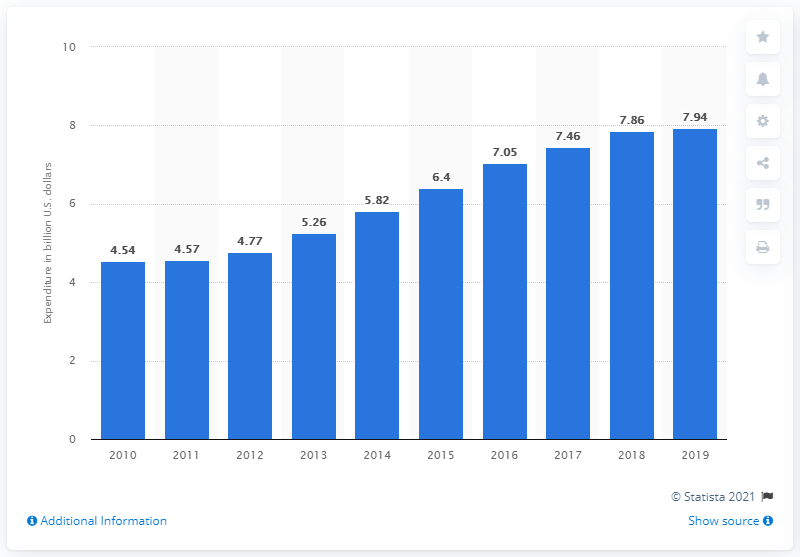Outline some significant characteristics in this image. In 2010, the dollar amount of inbound tourism spending in the Dominican Republic totaled approximately $4.54 billion. 